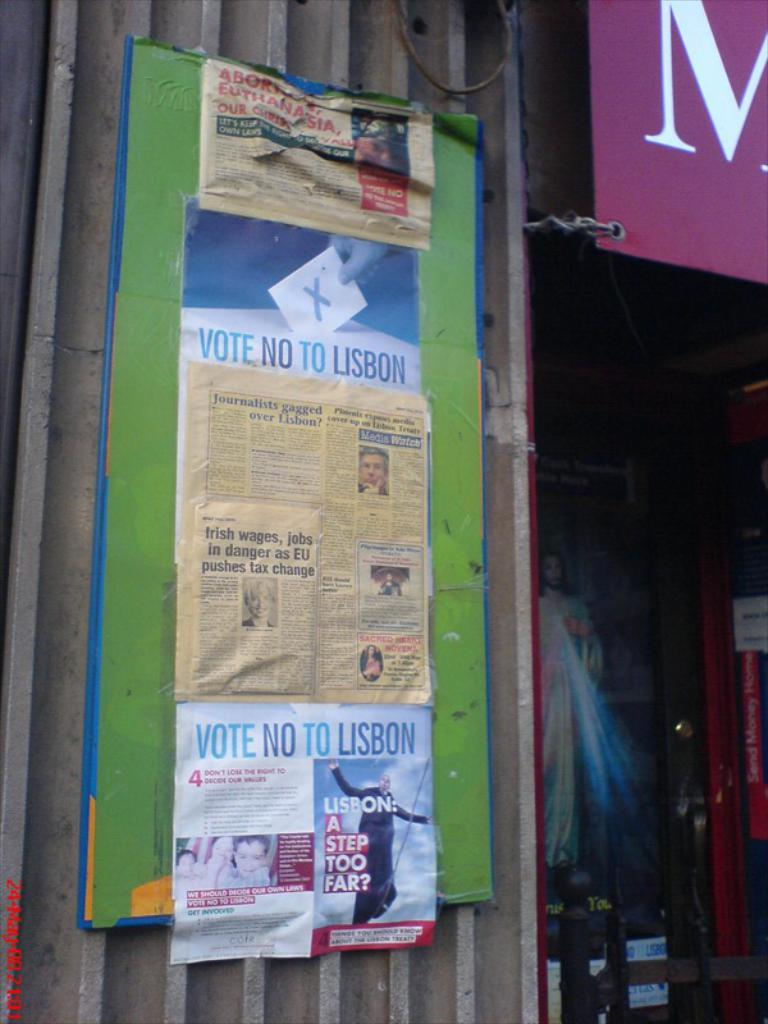What color is the board that is visible in the image? There is a green colored board in the image. What is attached to the green board? Papers are attached to the green board. Are there any other boards visible in the image? Yes, there is a pink colored board in the image. What other objects can be seen in the image besides the boards? There are other objects visible in the image. What type of cap is the wall wearing in the image? There is no cap or wall present in the image; it features green and pink colored boards with papers attached. 